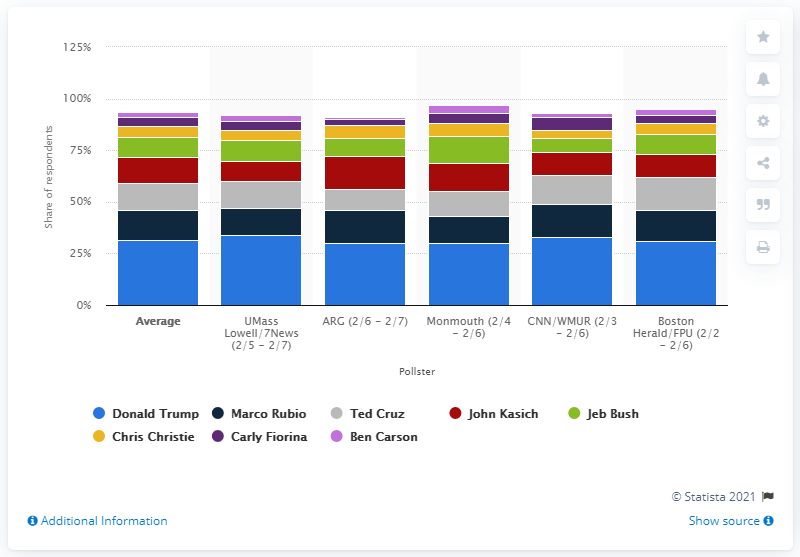Specify some key components in this picture. As of February 7, 2016, Donald Trump was leading the polls. 